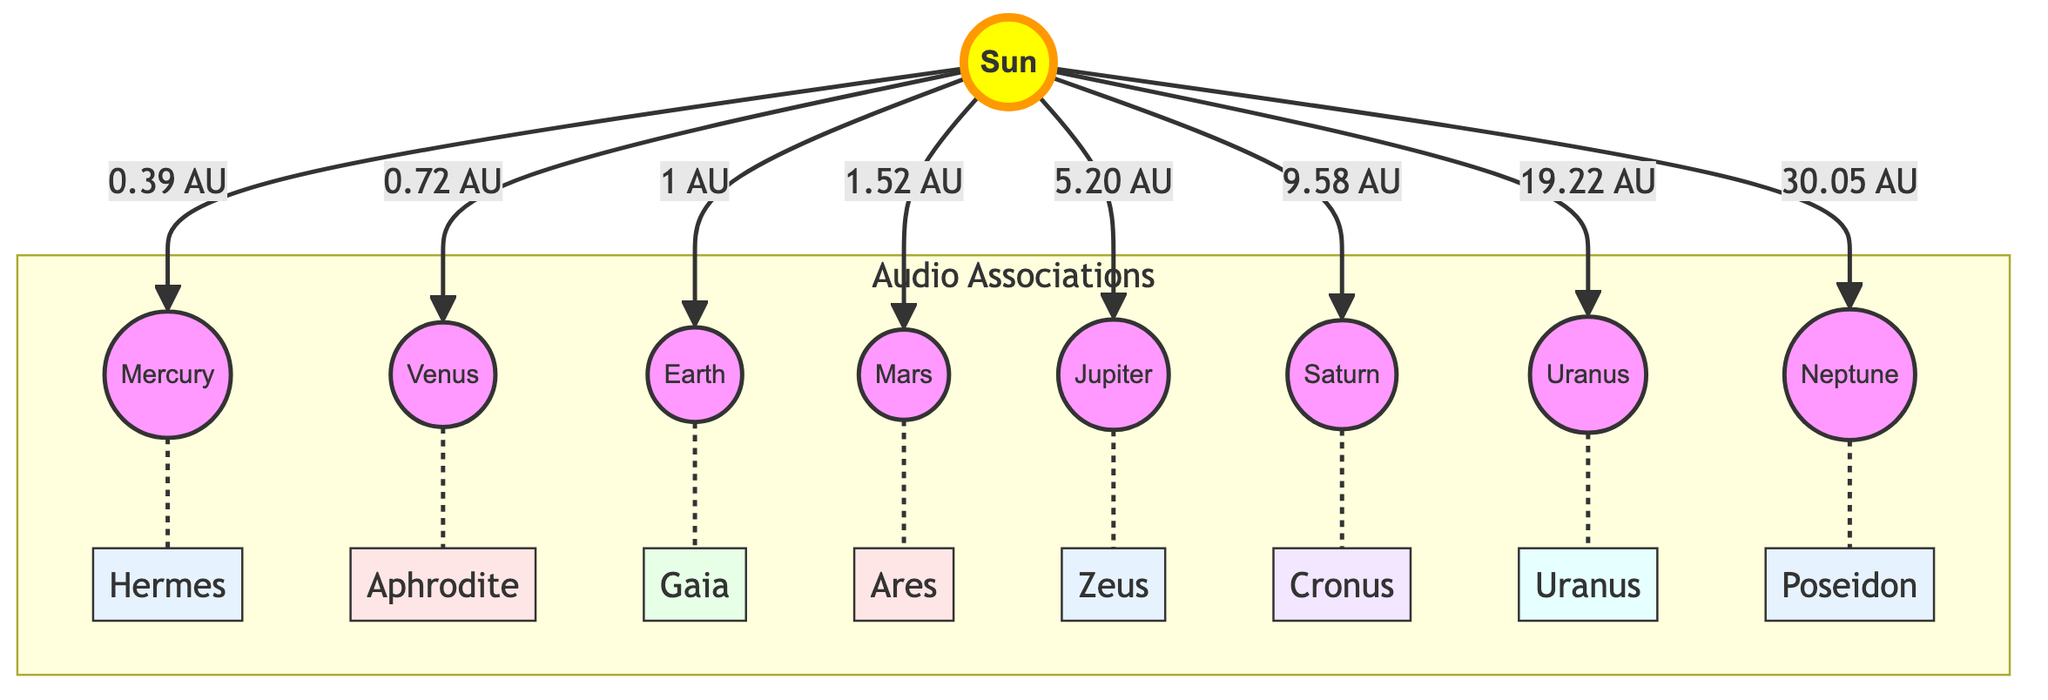What is the distance from the Sun to Mars? The diagram indicates that the distance from the Sun to Mars is represented as 1.52 AU. Therefore, the value shown is the direct mapping from the Sun to Mars.
Answer: 1.52 AU Which planet is associated with Hermes? The diagram connects Mercury with Hermes through a dashed line, indicating an audio association. This relationship is explicitly labeled.
Answer: Mercury How many planets are listed in the diagram? By counting the nodes representing planets (Mercury, Venus, Earth, Mars, Jupiter, Saturn, Uranus, and Neptune), there are a total of 8 listed.
Answer: 8 What is the association of Earth in the diagram? The diagram shows that Earth is associated with Gaia, which is illustrated through the dashed line connecting Earth to the name Gaia.
Answer: Gaia Which planet is located at a distance of 9.58 AU from the Sun? Referring to the visual connections in the diagram, Saturn is linked to the Sun with the distance labeled as 9.58 AU, making it the correct answer.
Answer: Saturn Which mythological figure is linked to Jupiter in the diagram? The diagram shows a connection between Jupiter and Zeus through a dashed line, indicating that Zeus is the associated figure for Jupiter.
Answer: Zeus What is the distance from the Sun to Neptune? The diagram specifies that the distance from the Sun to Neptune is indicated as 30.05 AU, so this is the direct measurement provided by the diagram.
Answer: 30.05 AU Which two planets are associated with figures from the same mythology category? The associations of Mercury (Hermes) and Jupiter (Zeus) can be determined to be both linked to Greek mythology. Thus, these two planets share this thematic connection.
Answer: Mercury, Jupiter 